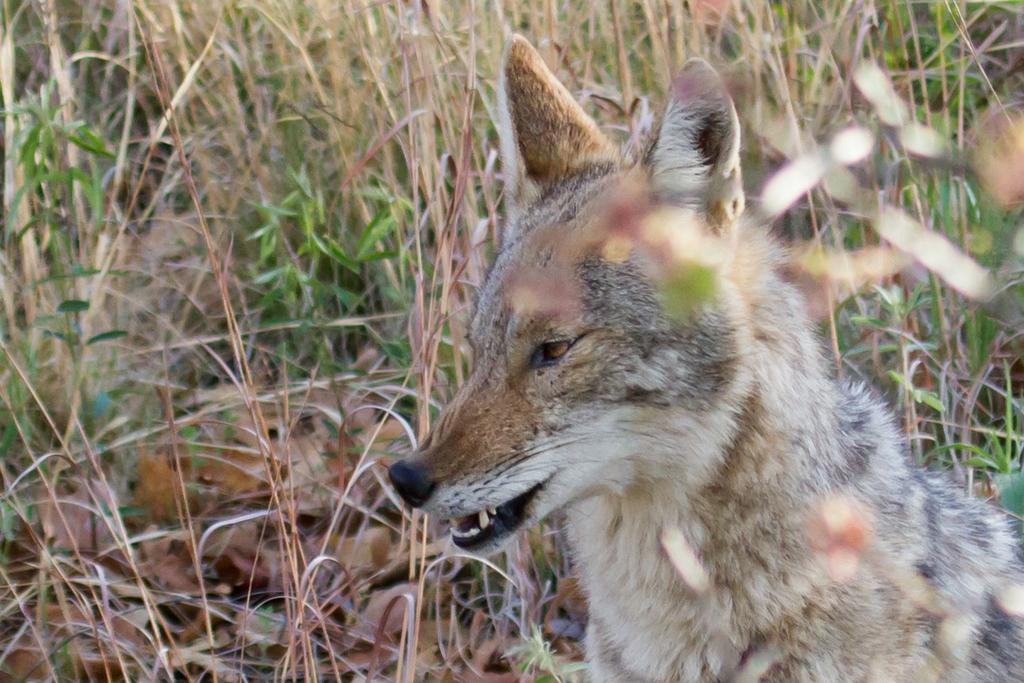What is the main subject in the foreground of the image? There is an animal in the foreground of the image. What type of environment can be seen in the background of the image? There is grass visible in the background of the image. How many fingers can be seen in the image? There are no fingers visible in the image. What type of picture is hanging on the wall in the image? There is no picture hanging on the wall in the image. 